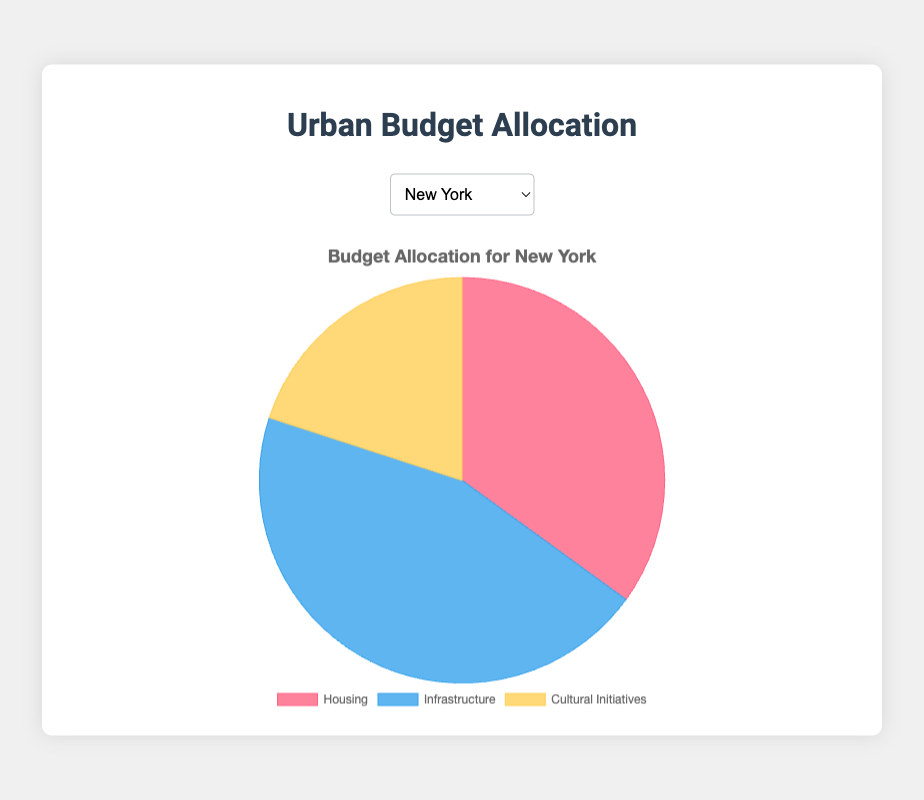What's the total budget allocation for housing, infrastructure, and cultural initiatives in New York? From the pie chart for New York, the sectors of housing, infrastructure, and cultural initiatives have percentages of 35%, 45%, and 20% respectively. Adding these values gives: 35 + 45 + 20 = 100.
Answer: 100 Which city allocates the most significant percentage of its budget to infrastructure? By comparing the percentages for infrastructure across all cities, we find that San Francisco allocates the highest percentage to infrastructure at 55%.
Answer: San Francisco How does the budget allocation for housing in Seattle compare to that in Los Angeles? Seattle allocates 35% to housing, while Los Angeles allocates 40%. So, Seattle allocates 5% less of its budget to housing compared to Los Angeles.
Answer: 5% less If a city were to shift 5% of its housing budget to its cultural initiatives budget, what would be the new percentages for housing and cultural initiatives in Chicago? Initially, Chicago has 30% for housing and 20% for cultural initiatives. If 5% is shifted from housing to cultural initiatives, the new values would be 30 - 5 = 25% for housing and 20 + 5 = 25% for cultural initiatives.
Answer: 25% for housing and 25% for cultural initiatives Which city has the least budget allocation towards cultural initiatives? By comparing the cultural initiatives percentages of all cities, Seattle has the least allocation at 15%.
Answer: Seattle What is the difference in budget allocation between infrastructure and cultural initiatives in Chicago? Chicago allocates 50% to infrastructure and 20% to cultural initiatives. The difference is 50 - 20 = 30%.
Answer: 30% If the average budget allocation across all cities for cultural initiatives is calculated, what is the result? Adding the percentages for cultural initiatives across all cities (20% + 20% + 20% + 20% + 15%) and dividing by the number of cities (5), we get (20 + 20 + 20 + 20 + 15) / 5 = 19%.
Answer: 19% How does the budget allocation for infrastructure in New York compare to that in Seattle? New York allocates 45% to infrastructure, while Seattle allocates 50%. Therefore, Seattle allocates 5% more to infrastructure compared to New York.
Answer: 5% more What is the total budget allocation for both housing and cultural initiatives in Los Angeles? Los Angeles allocates 40% to housing and 20% to cultural initiatives. Adding these values gives: 40 + 20 = 60%.
Answer: 60% Which part of the budget for San Francisco is larger: housing or cultural initiatives, and by how much? San Francisco allocates 25% to housing and 20% to cultural initiatives. Housing is larger by 25 - 20 = 5%.
Answer: Housing by 5% 